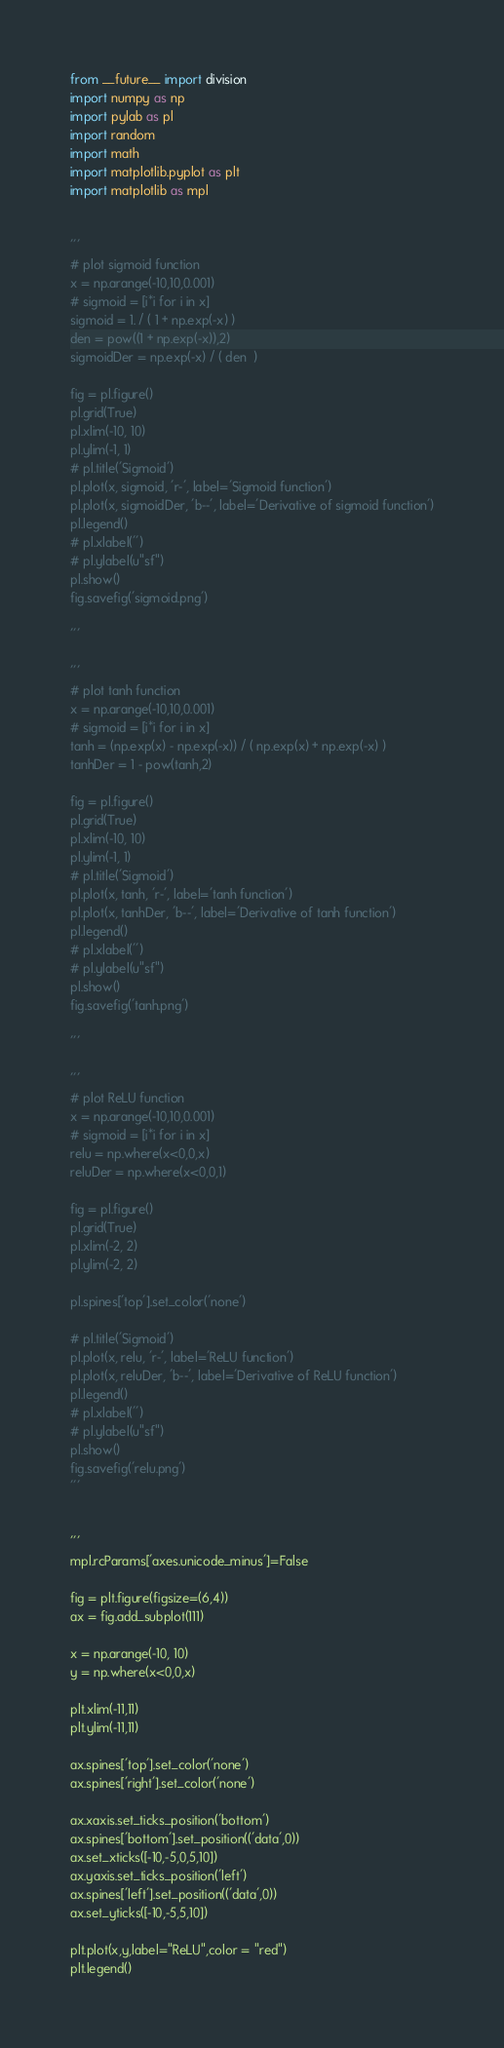<code> <loc_0><loc_0><loc_500><loc_500><_Python_>from __future__ import division
import numpy as np
import pylab as pl
import random
import math
import matplotlib.pyplot as plt
import matplotlib as mpl


'''
# plot sigmoid function
x = np.arange(-10,10,0.001)
# sigmoid = [i*i for i in x]
sigmoid = 1. / ( 1 + np.exp(-x) )
den = pow((1 + np.exp(-x)),2)
sigmoidDer = np.exp(-x) / ( den  )

fig = pl.figure()
pl.grid(True)
pl.xlim(-10, 10)
pl.ylim(-1, 1)
# pl.title('Sigmoid')
pl.plot(x, sigmoid, 'r-', label='Sigmoid function')
pl.plot(x, sigmoidDer, 'b--', label='Derivative of sigmoid function')
pl.legend()
# pl.xlabel('')
# pl.ylabel(u"sf")
pl.show()
fig.savefig('sigmoid.png')

'''

'''
# plot tanh function
x = np.arange(-10,10,0.001)
# sigmoid = [i*i for i in x]
tanh = (np.exp(x) - np.exp(-x)) / ( np.exp(x) + np.exp(-x) )
tanhDer = 1 - pow(tanh,2)

fig = pl.figure()
pl.grid(True)
pl.xlim(-10, 10)
pl.ylim(-1, 1)
# pl.title('Sigmoid')
pl.plot(x, tanh, 'r-', label='tanh function')
pl.plot(x, tanhDer, 'b--', label='Derivative of tanh function')
pl.legend()
# pl.xlabel('')
# pl.ylabel(u"sf")
pl.show()
fig.savefig('tanh.png')

'''

'''
# plot ReLU function
x = np.arange(-10,10,0.001)
# sigmoid = [i*i for i in x]
relu = np.where(x<0,0,x)
reluDer = np.where(x<0,0,1)

fig = pl.figure()
pl.grid(True)
pl.xlim(-2, 2)
pl.ylim(-2, 2)

pl.spines['top'].set_color('none')

# pl.title('Sigmoid')
pl.plot(x, relu, 'r-', label='ReLU function')
pl.plot(x, reluDer, 'b--', label='Derivative of ReLU function')
pl.legend()
# pl.xlabel('')
# pl.ylabel(u"sf")
pl.show()
fig.savefig('relu.png')
'''


'''
mpl.rcParams['axes.unicode_minus']=False

fig = plt.figure(figsize=(6,4))
ax = fig.add_subplot(111)

x = np.arange(-10, 10)
y = np.where(x<0,0,x)

plt.xlim(-11,11)
plt.ylim(-11,11)

ax.spines['top'].set_color('none')
ax.spines['right'].set_color('none')

ax.xaxis.set_ticks_position('bottom')
ax.spines['bottom'].set_position(('data',0))
ax.set_xticks([-10,-5,0,5,10])
ax.yaxis.set_ticks_position('left')
ax.spines['left'].set_position(('data',0))
ax.set_yticks([-10,-5,5,10])

plt.plot(x,y,label="ReLU",color = "red")
plt.legend()</code> 